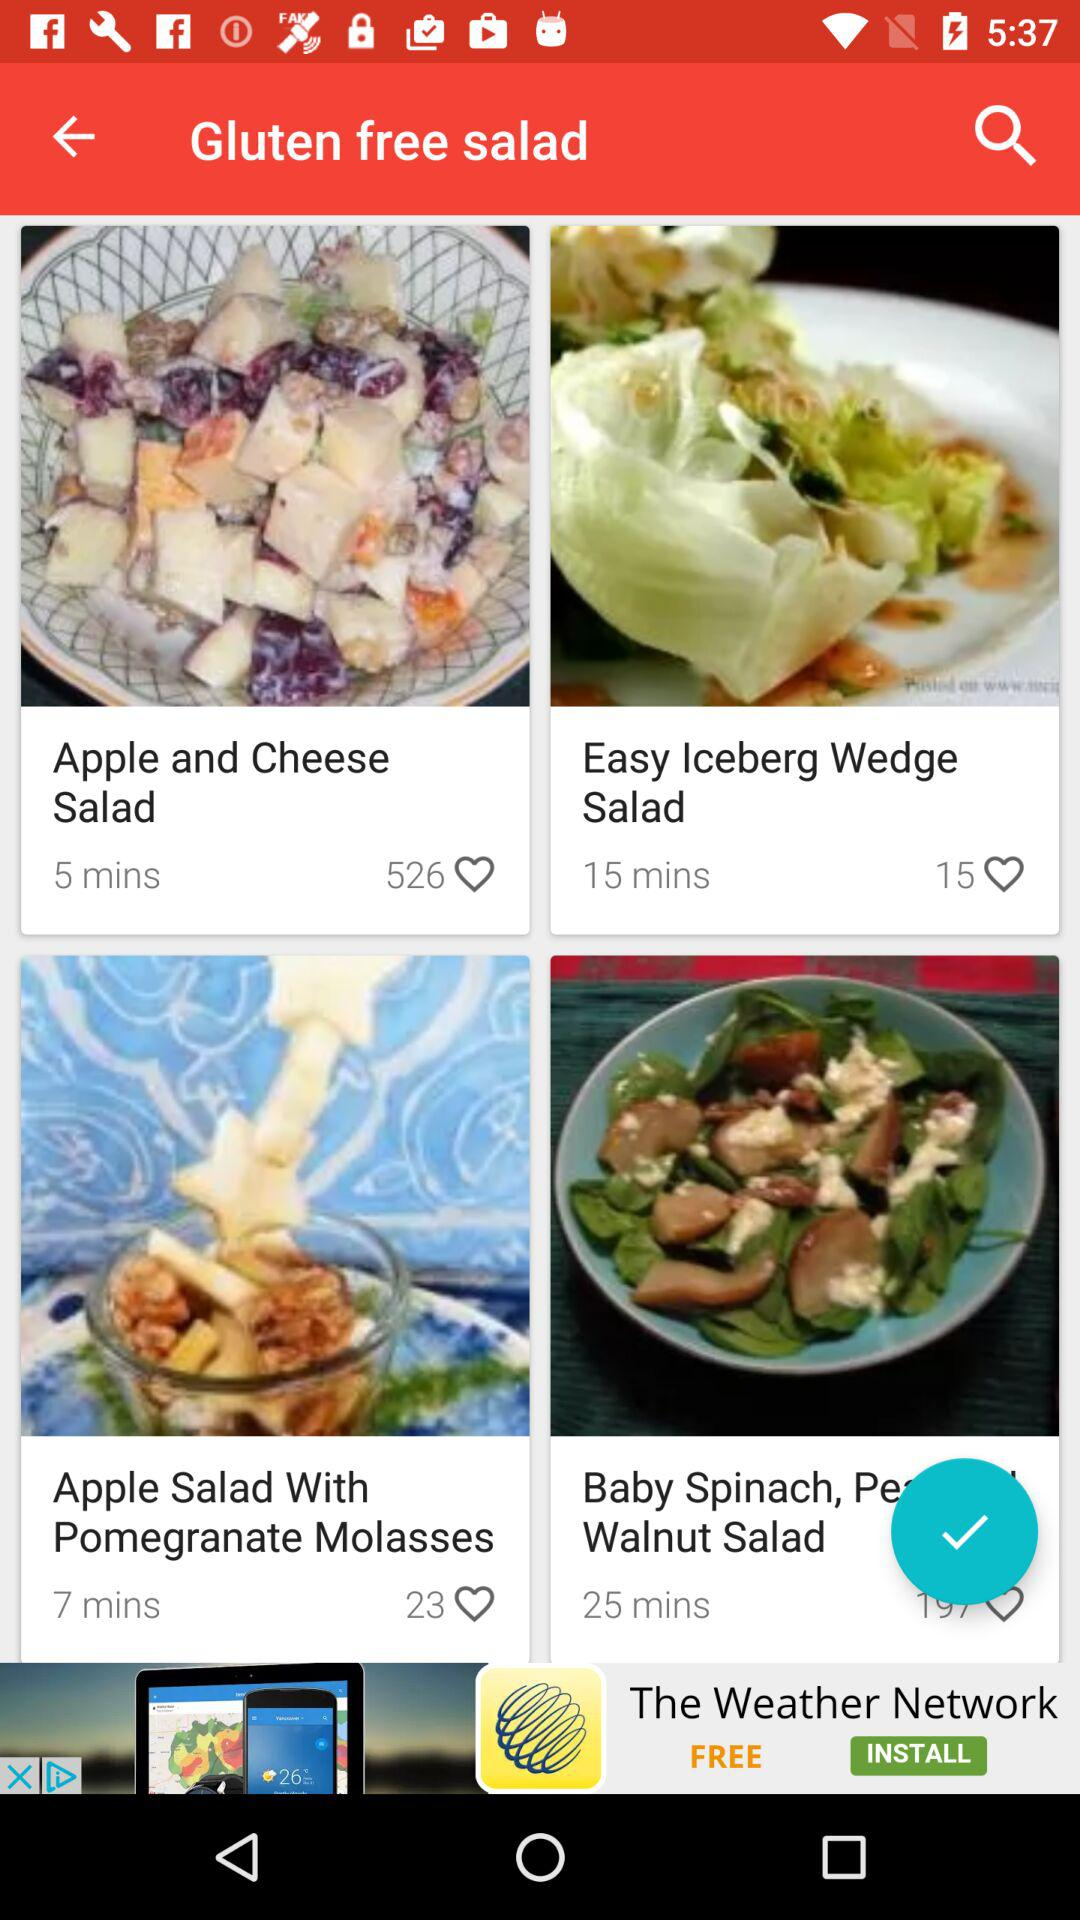How many people have liked the "Apple Salad With Pomegranate Molasses"? There are 23 people who have liked the "Apple Salad With Pomegranate Molasses". 